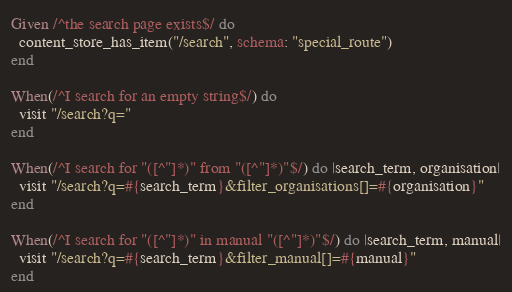Convert code to text. <code><loc_0><loc_0><loc_500><loc_500><_Ruby_>Given /^the search page exists$/ do
  content_store_has_item("/search", schema: "special_route")
end

When(/^I search for an empty string$/) do
  visit "/search?q="
end

When(/^I search for "([^"]*)" from "([^"]*)"$/) do |search_term, organisation|
  visit "/search?q=#{search_term}&filter_organisations[]=#{organisation}"
end

When(/^I search for "([^"]*)" in manual "([^"]*)"$/) do |search_term, manual|
  visit "/search?q=#{search_term}&filter_manual[]=#{manual}"
end
</code> 